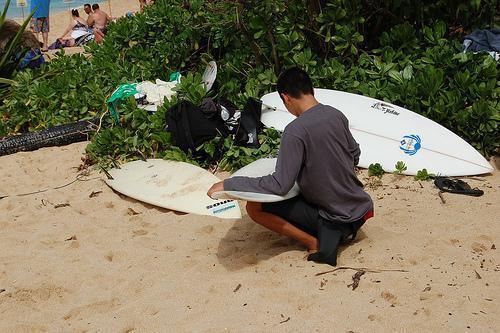How many surfboards is the man holding?
Give a very brief answer. 1. 